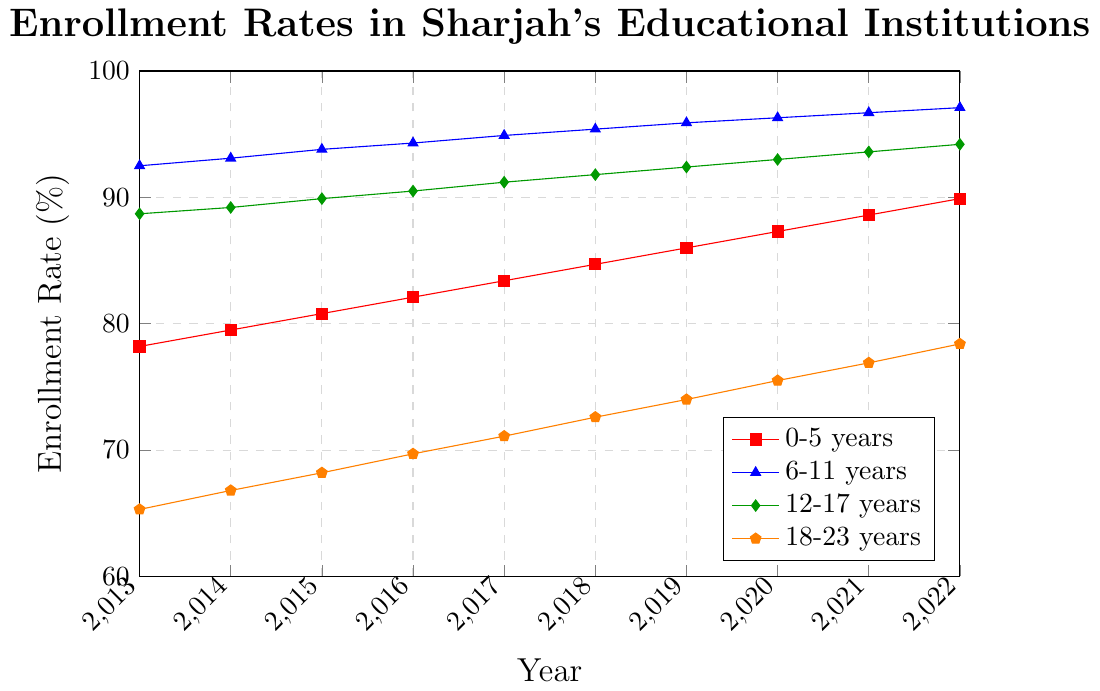Which age group had the highest enrollment rate in 2022? To find which age group had the highest enrollment rate, look at the endpoints of each line in 2022. The group with the highest endpoint is the one with the highest enrollment rate. The 6-11 years age group has the highest enrollment rate at 97.1%.
Answer: 6-11 years What is the difference in enrollment rate between the 0-5 years and 18-23 years age groups in 2013? Find the enrollment rates for both the 0-5 years and 18-23 years age groups in 2013, which are 78.2% and 65.3% respectively. Subtract the enrollment rate of the 18-23 years from the 0-5 years: 78.2% - 65.3% = 12.9%.
Answer: 12.9% By how many percentage points did the enrollment rate for the 12-17 years age group increase from 2013 to 2022? Look at the enrollment rates for the 12-17 years age group in 2013 and 2022, which are 88.7% and 94.2% respectively. Subtract the 2013 rate from the 2022 rate: 94.2% - 88.7% = 5.5%.
Answer: 5.5% Which age group shows the most consistent increase in enrollment rates over the decade? Observe the slopes of the lines for each age group from 2013 to 2022. The 6-11 years age group has the most linear and consistent increase, with no large slopes or dips, indicating a steady rise.
Answer: 6-11 years What is the average enrollment rate for the 18-23 years age group from 2013 to 2022? Add up the enrollment rates from 2013 to 2022: 65.3 + 66.8 + 68.2 + 69.7 + 71.1 + 72.6 + 74.0 + 75.5 + 76.9 + 78.4 = 718.5. Divide this sum by 10 (the number of years) to get the average: 718.5 / 10 = 71.85%.
Answer: 71.85% Which age group had the second-lowest enrollment rate in 2017? Look at the enrollment rates for each age group in 2017: 83.4% (0-5 years), 94.9% (6-11 years), 91.2% (12-17 years), and 71.1% (18-23 years). The second-lowest rate is 83.4% for the 0-5 years age group.
Answer: 0-5 years How does the enrollment trend for the 0-5 years age group compare to the 18-23 years age group? Analyze the trend lines for both age groups from 2013 to 2022. Both show a steady increase over the decade, but the 0-5 years group starts higher and increases more rapidly, while the 18-23 years group starts lower and increases more gradually.
Answer: 0-5 years increases more rapidly If you sum the enrollment rates for all age groups in 2020, what is the total percentage? Add the enrollment rates for all age groups in 2020: 87.3% (0-5 years), 96.3% (6-11 years), 93.0% (12-17 years), and 75.5% (18-23 years). The total is 87.3 + 96.3 + 93.0 + 75.5 = 352.1%.
Answer: 352.1% What is the difference in the enrollment rate growth between the 0-5 years and the 18-23 years age groups from 2016 to 2022? Calculate the growth for each age group from 2016 to 2022. For the 0-5 years: 89.9% - 82.1% = 7.8%. For the 18-23 years: 78.4% - 69.7% = 8.7%. The difference in growth is 8.7% - 7.8% = 0.9%.
Answer: 0.9% 